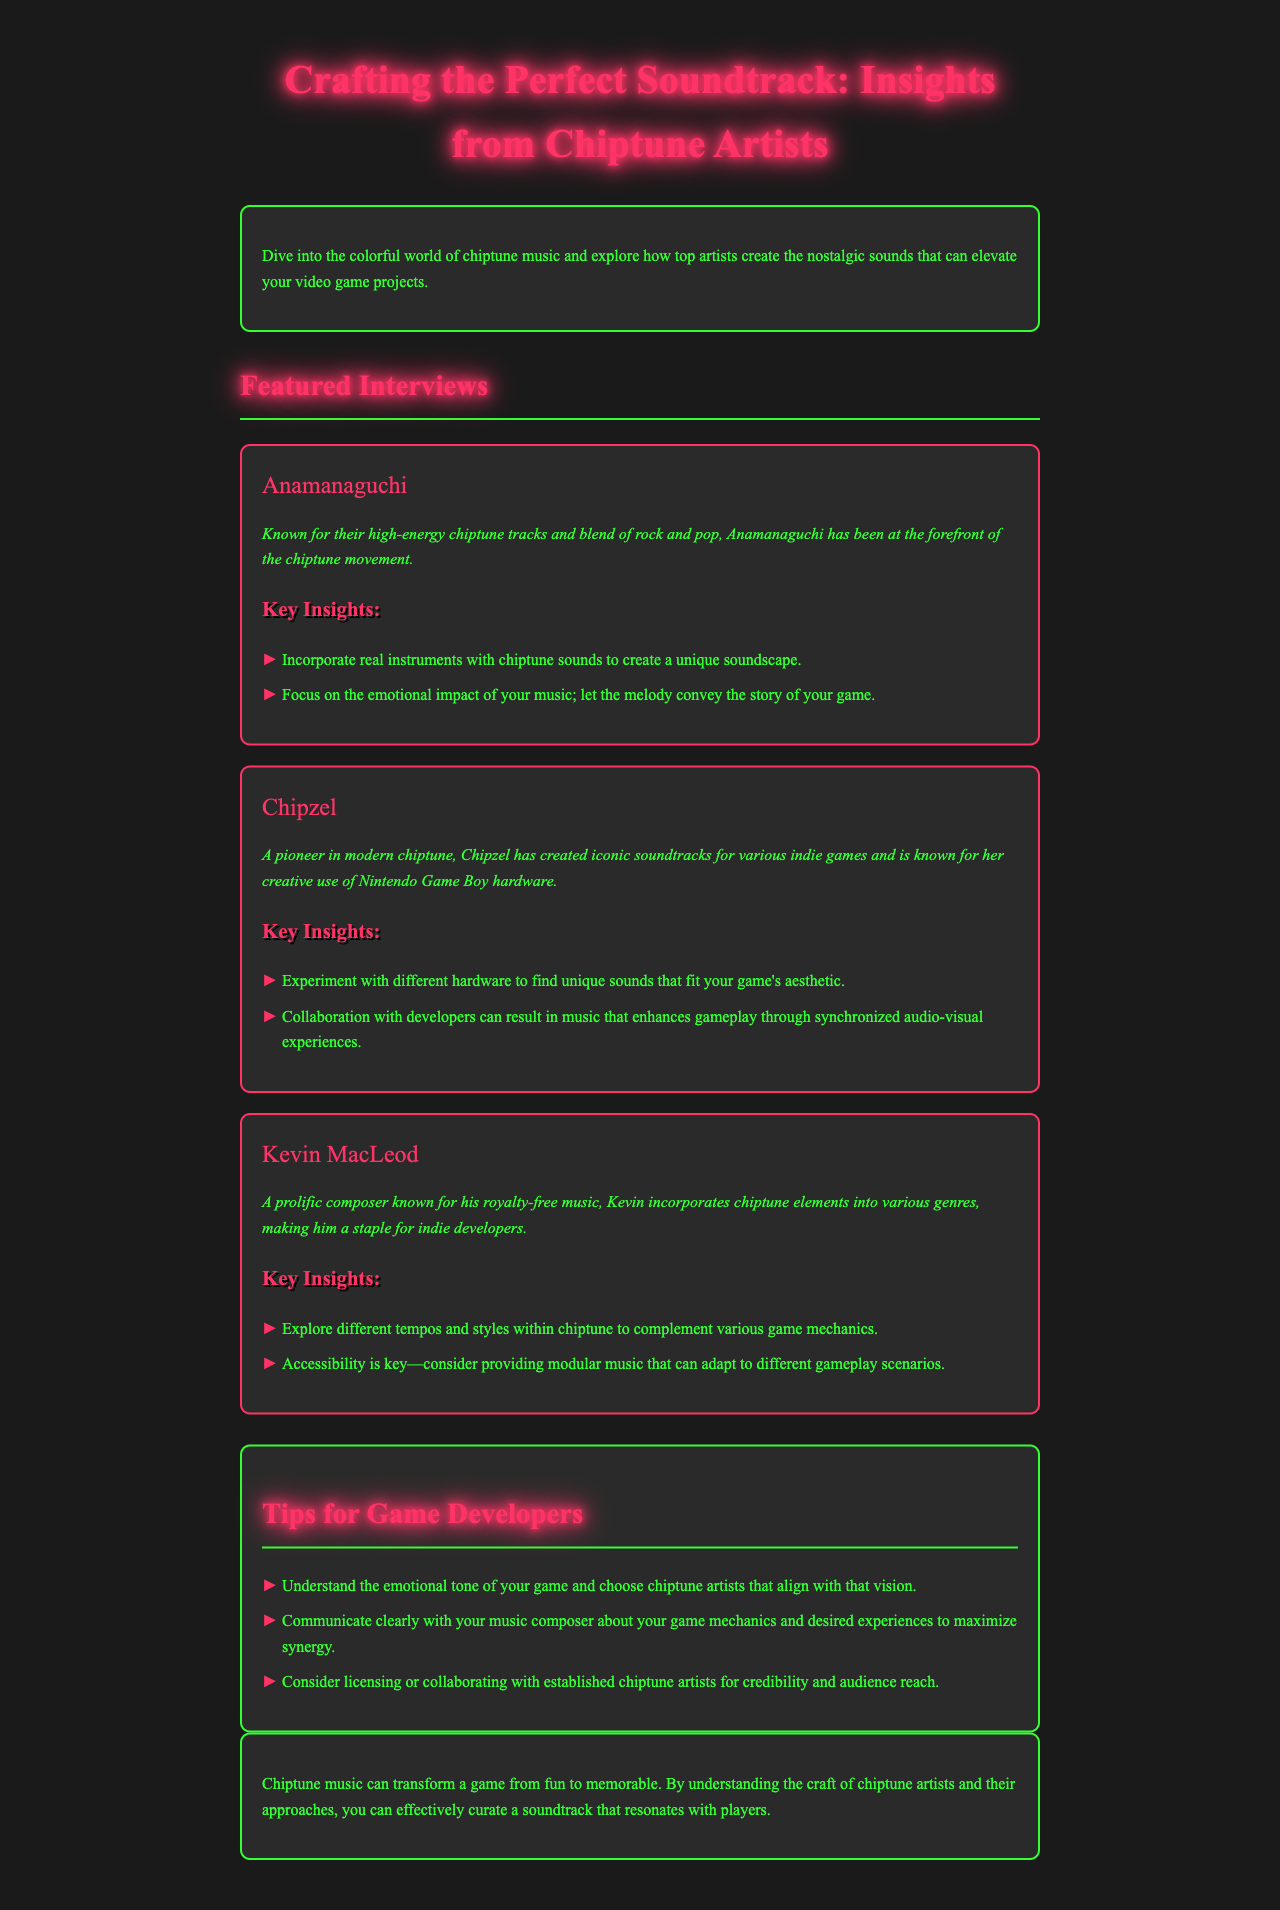what is the name of the first featured artist? The first featured artist in the document is Anamanaguchi.
Answer: Anamanaguchi who is known for using Nintendo Game Boy hardware? Chipzel is specifically mentioned as a pioneer known for her creative use of Nintendo Game Boy hardware.
Answer: Chipzel how many key insights does Kevin MacLeod offer? Kevin MacLeod offers two key insights as indicated in the document.
Answer: 2 what type of music can transform a game from fun to memorable? The document states that chiptune music can transform a game from fun to memorable.
Answer: chiptune music what is suggested for collaborations between developers and musicians? The document suggests that collaboration with developers can result in music that enhances gameplay through synchronized audio-visual experiences.
Answer: enhances gameplay what color is used for the text in the newsletter? The text color in the newsletter is indicated as #33ff33, which is a shade of green.
Answer: #33ff33 how should game developers communicate with music composers? Game developers should communicate clearly with their music composer about game mechanics and desired experiences.
Answer: communicate clearly how many tips are listed for game developers? There are three tips listed for game developers in the tips section of the document.
Answer: 3 